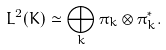<formula> <loc_0><loc_0><loc_500><loc_500>L ^ { 2 } ( K ) \simeq \bigoplus _ { k } \pi _ { k } \otimes \pi ^ { * } _ { k } .</formula> 